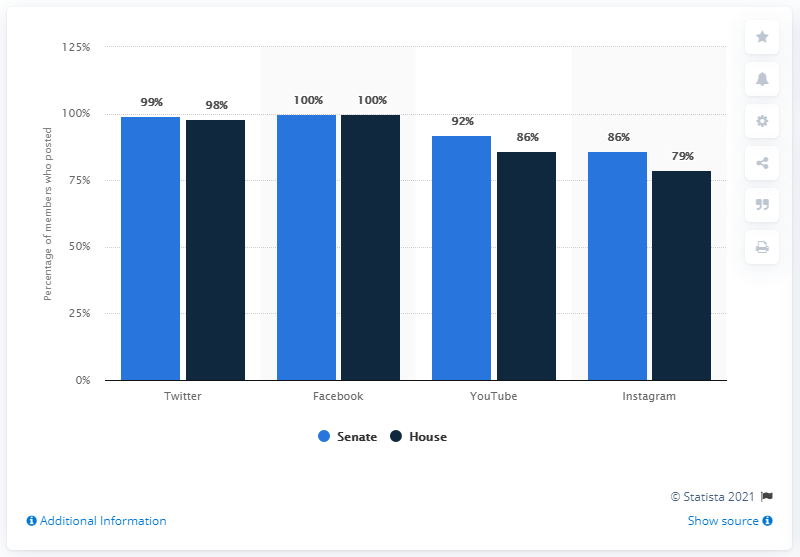Indicate a few pertinent items in this graphic. In 2020, the vast majority of senators, or 98%, were reported to use Twitter as their primary social media platform. 